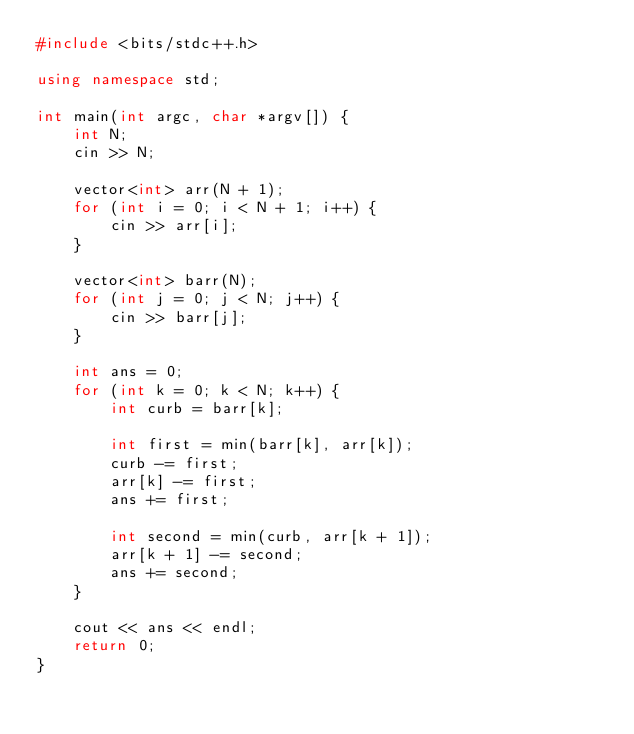<code> <loc_0><loc_0><loc_500><loc_500><_C++_>#include <bits/stdc++.h>

using namespace std;

int main(int argc, char *argv[]) {
    int N;
    cin >> N;
    
    vector<int> arr(N + 1);
    for (int i = 0; i < N + 1; i++) {
        cin >> arr[i];
    }

    vector<int> barr(N);
    for (int j = 0; j < N; j++) {
        cin >> barr[j];
    }

    int ans = 0;
    for (int k = 0; k < N; k++) {
        int curb = barr[k];

        int first = min(barr[k], arr[k]);
        curb -= first;
        arr[k] -= first;
        ans += first;

        int second = min(curb, arr[k + 1]);
        arr[k + 1] -= second;
        ans += second;
    }

    cout << ans << endl;
    return 0;
}
</code> 